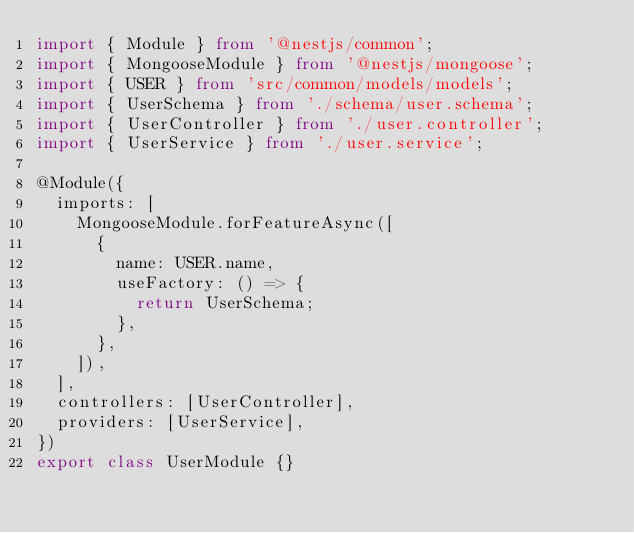Convert code to text. <code><loc_0><loc_0><loc_500><loc_500><_TypeScript_>import { Module } from '@nestjs/common';
import { MongooseModule } from '@nestjs/mongoose';
import { USER } from 'src/common/models/models';
import { UserSchema } from './schema/user.schema';
import { UserController } from './user.controller';
import { UserService } from './user.service';

@Module({
  imports: [
    MongooseModule.forFeatureAsync([
      {
        name: USER.name,
        useFactory: () => {
          return UserSchema;
        },
      },
    ]),
  ],
  controllers: [UserController],
  providers: [UserService],
})
export class UserModule {}
</code> 